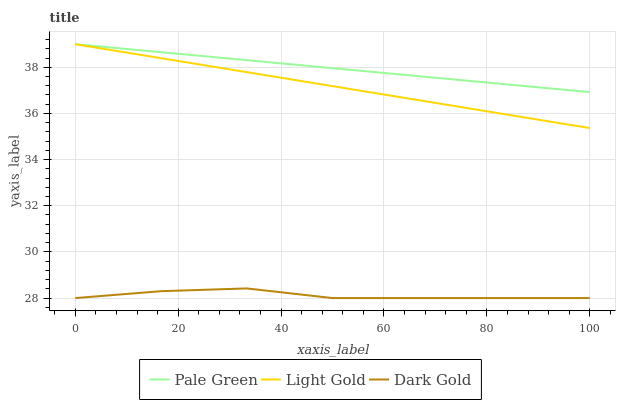Does Dark Gold have the minimum area under the curve?
Answer yes or no. Yes. Does Pale Green have the maximum area under the curve?
Answer yes or no. Yes. Does Light Gold have the minimum area under the curve?
Answer yes or no. No. Does Light Gold have the maximum area under the curve?
Answer yes or no. No. Is Pale Green the smoothest?
Answer yes or no. Yes. Is Dark Gold the roughest?
Answer yes or no. Yes. Is Light Gold the smoothest?
Answer yes or no. No. Is Light Gold the roughest?
Answer yes or no. No. Does Dark Gold have the lowest value?
Answer yes or no. Yes. Does Light Gold have the lowest value?
Answer yes or no. No. Does Light Gold have the highest value?
Answer yes or no. Yes. Does Dark Gold have the highest value?
Answer yes or no. No. Is Dark Gold less than Pale Green?
Answer yes or no. Yes. Is Pale Green greater than Dark Gold?
Answer yes or no. Yes. Does Light Gold intersect Pale Green?
Answer yes or no. Yes. Is Light Gold less than Pale Green?
Answer yes or no. No. Is Light Gold greater than Pale Green?
Answer yes or no. No. Does Dark Gold intersect Pale Green?
Answer yes or no. No. 